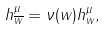<formula> <loc_0><loc_0><loc_500><loc_500>h ^ { \mu } _ { \overline { w } } = \nu ( w ) h ^ { \mu } _ { w } ,</formula> 